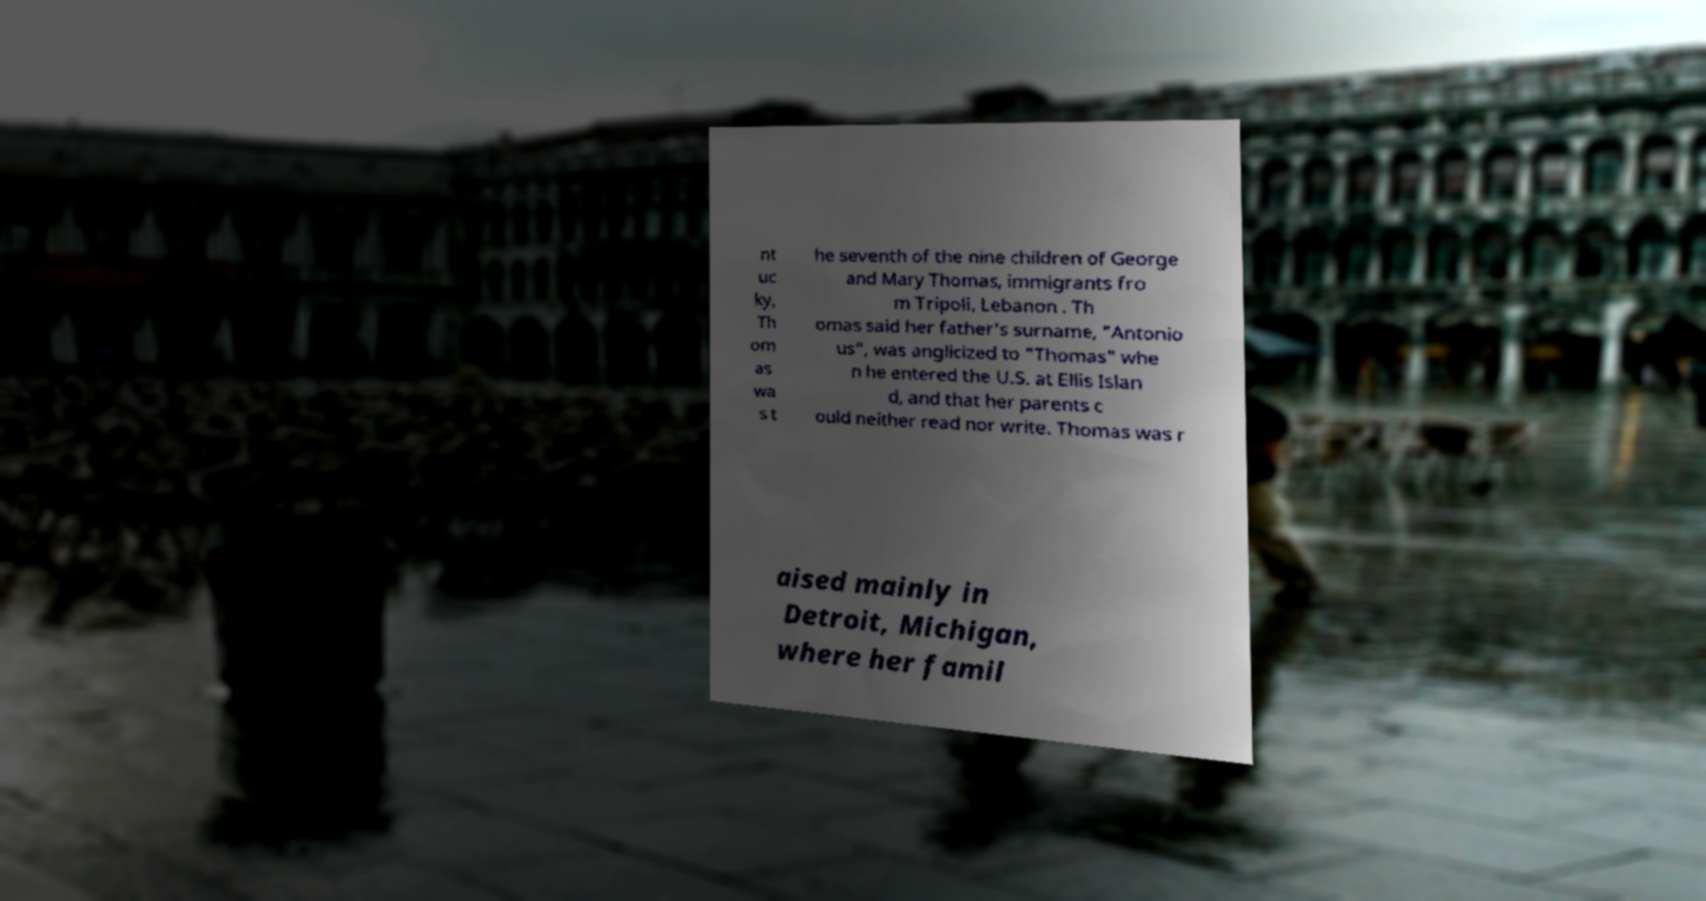There's text embedded in this image that I need extracted. Can you transcribe it verbatim? nt uc ky, Th om as wa s t he seventh of the nine children of George and Mary Thomas, immigrants fro m Tripoli, Lebanon . Th omas said her father's surname, "Antonio us", was anglicized to "Thomas" whe n he entered the U.S. at Ellis Islan d, and that her parents c ould neither read nor write. Thomas was r aised mainly in Detroit, Michigan, where her famil 